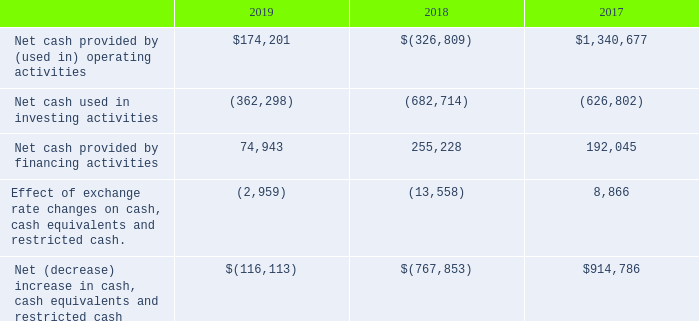Cash Flows
The following table summarizes key cash flow activity for the years ended December 31, 2019, 2018, and 2017 (in thousands):
Operating Activities
The increase in net cash provided by operating activities during 2019 was primarily driven by higher cash proceeds from sales of systems projects, including the Sunshine Valley, Sun Streams, and California Flats projects, and advance payments received for sales of solar modules prior to the step down in the U.S. investment tax credit as discussed above. These increases were partially offset by operating expenditures associated with initial ramp of certain Series 6 manufacturing lines and expenditures for the construction of certain projects.
Investing Activities
The decrease in net cash used in investing activities during 2019 was primarily due to higher net sales of marketable securities and restricted investments, partially offset by proceeds associated with the sale of our interests in 8point3 and its subsidiaries in 2018.
Financing Activities
The decrease in net cash provided by financing activities during 2019 was primarily the result of lower net proceeds from borrowings under project specific debt financings associated with the construction of certain projects in Australia, Japan, and India.
What are the reasons for the increase in cash provided by operating activities in 2019? Primarily driven by higher cash proceeds from sales of systems projects, including the sunshine valley, sun streams, and california flats projects, and advance payments received for sales of solar modules prior to the step down in the u.s. investment tax credit as discussed above. What are the reasons for the decrease in cash used in investing activities? The decrease in net cash used in investing activities during 2019 was primarily due to higher net sales of marketable securities and restricted investments, partially offset by proceeds associated with the sale of our interests in 8point3 and its subsidiaries in 2018. What are the reasons for the decrease in cash provided by financing activities? The decrease in net cash provided by financing activities during 2019 was primarily the result of lower net proceeds from borrowings under project specific debt financings associated with the construction of certain projects in australia, japan, and india. What is the increase in cash provided by operating activities from 2018 to 2019?
Answer scale should be: thousand. 174,201 - (-326,809) 
Answer: 501010. What is the difference in net cash and cash equivalents between 2019 and 2018?
Answer scale should be: thousand.  (-116,113) - (-767,853) 
Answer: 651740. What is the percentage decrease in cash provided in financing activities from 2018 to 2019?
Answer scale should be: percent. (255,228 - 74,943) / 255,228 
Answer: 70.64. 